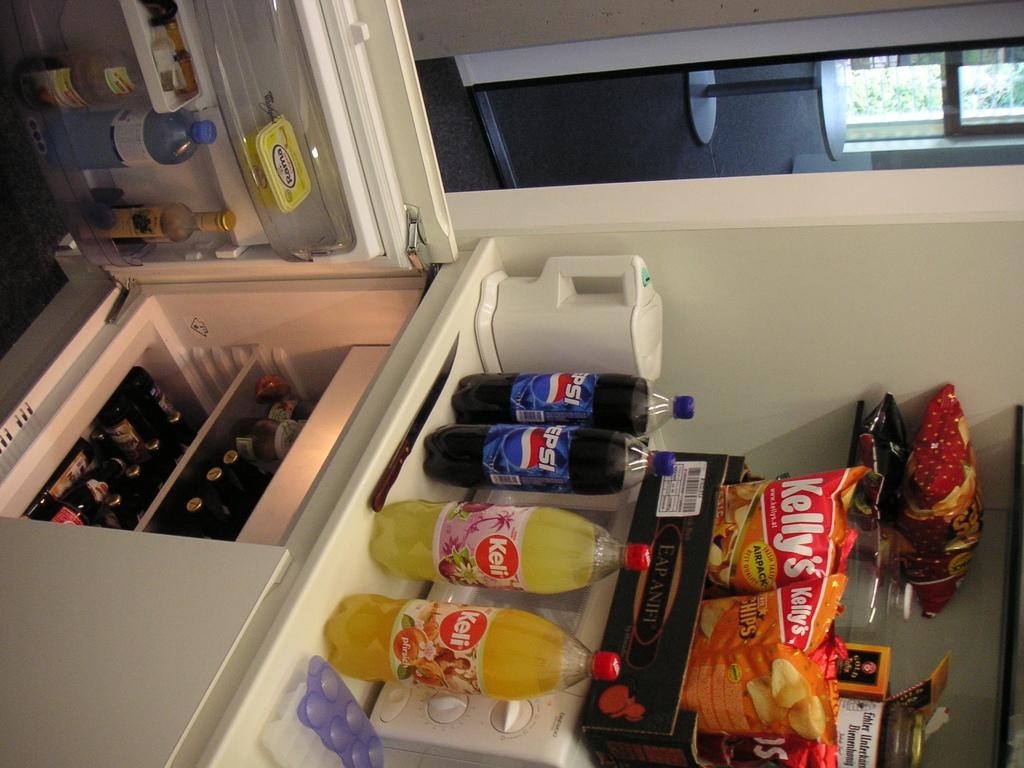<image>
Offer a succinct explanation of the picture presented. A kitchen counter with Pepsi and Keli sodas on it and Kelly's potato chips. 